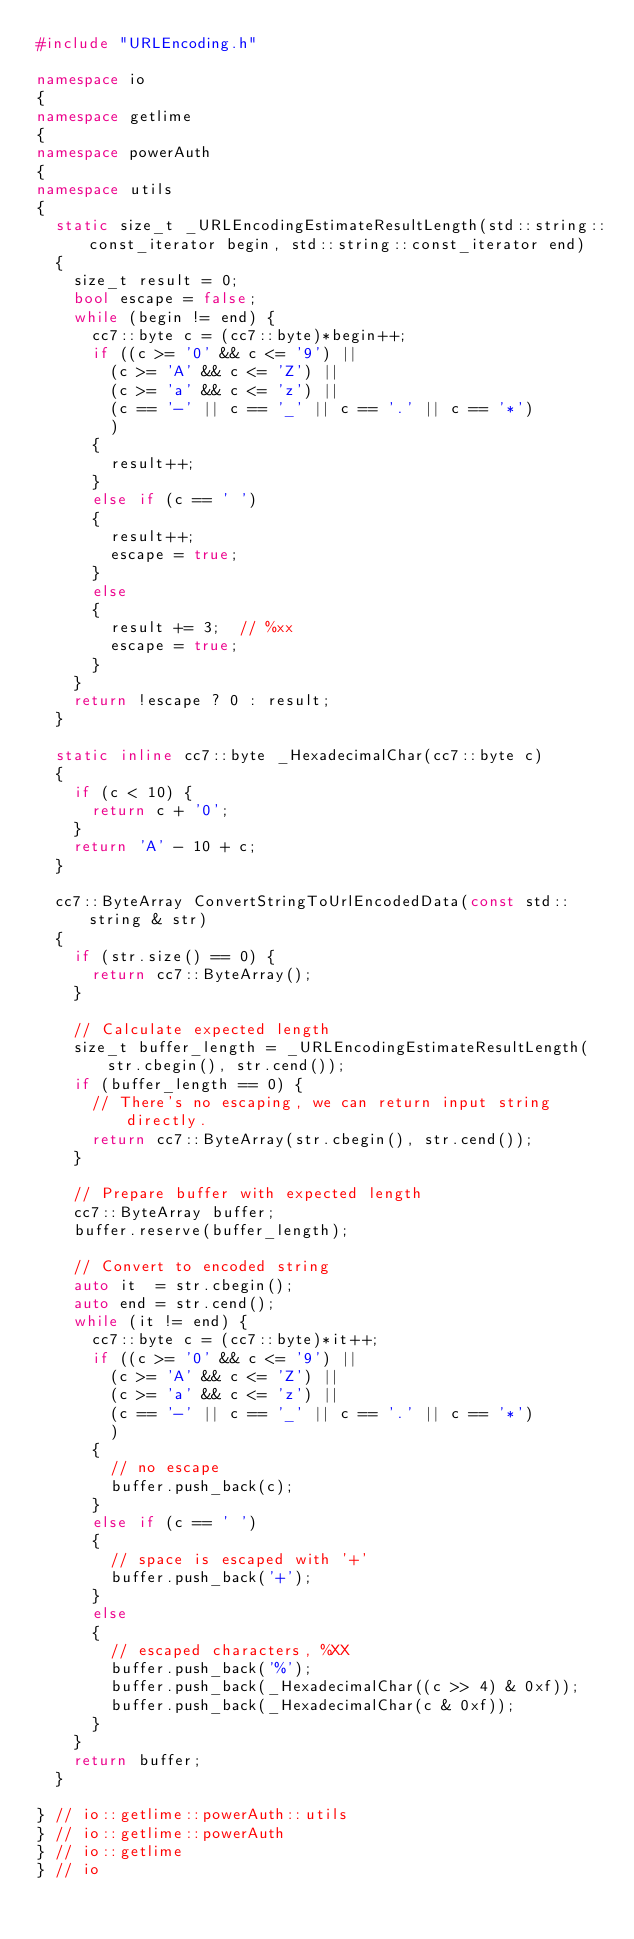<code> <loc_0><loc_0><loc_500><loc_500><_C++_>#include "URLEncoding.h"

namespace io
{
namespace getlime
{
namespace powerAuth
{
namespace utils
{
	static size_t _URLEncodingEstimateResultLength(std::string::const_iterator begin, std::string::const_iterator end)
	{
		size_t result = 0;
		bool escape = false;
		while (begin != end) {
			cc7::byte c = (cc7::byte)*begin++;
			if ((c >= '0' && c <= '9') ||
				(c >= 'A' && c <= 'Z') ||
				(c >= 'a' && c <= 'z') ||
				(c == '-' || c == '_' || c == '.' || c == '*')
				)
			{
				result++;
			}
			else if (c == ' ')
			{
				result++;
				escape = true;
			}
			else
			{
				result += 3;	// %xx
				escape = true;
			}
		}
		return !escape ? 0 : result;
	}
	
	static inline cc7::byte _HexadecimalChar(cc7::byte c)
	{
		if (c < 10) {
			return c + '0';
		}
		return 'A' - 10 + c;
	}
	
	cc7::ByteArray ConvertStringToUrlEncodedData(const std::string & str)
	{
		if (str.size() == 0) {
			return cc7::ByteArray();
		}
		
		// Calculate expected length
		size_t buffer_length = _URLEncodingEstimateResultLength(str.cbegin(), str.cend());
		if (buffer_length == 0) {
			// There's no escaping, we can return input string directly.
			return cc7::ByteArray(str.cbegin(), str.cend());
		}
		
		// Prepare buffer with expected length
		cc7::ByteArray buffer;
		buffer.reserve(buffer_length);
		
		// Convert to encoded string
		auto it  = str.cbegin();
		auto end = str.cend();
		while (it != end) {
			cc7::byte c = (cc7::byte)*it++;
			if ((c >= '0' && c <= '9') ||
				(c >= 'A' && c <= 'Z') ||
				(c >= 'a' && c <= 'z') ||
				(c == '-' || c == '_' || c == '.' || c == '*')
				)
			{
				// no escape
				buffer.push_back(c);
			}
			else if (c == ' ')
			{
				// space is escaped with '+'
				buffer.push_back('+');
			}
			else
			{
				// escaped characters, %XX
				buffer.push_back('%');
				buffer.push_back(_HexadecimalChar((c >> 4) & 0xf));
				buffer.push_back(_HexadecimalChar(c & 0xf));
			}
		}
		return buffer;
	}
	
} // io::getlime::powerAuth::utils
} // io::getlime::powerAuth
} // io::getlime
} // io
</code> 